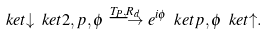<formula> <loc_0><loc_0><loc_500><loc_500>\ k e t { \downarrow } \ k e t { 2 , p , \phi } \stackrel { T _ { P } , R _ { d } } { \longrightarrow } e ^ { i \phi } \ k e t { p , \phi } \ k e t { \uparrow } .</formula> 